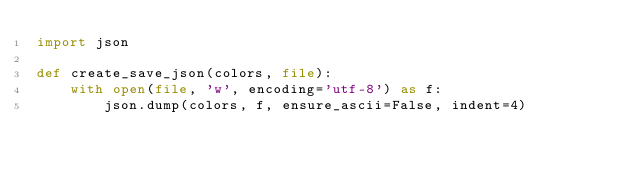<code> <loc_0><loc_0><loc_500><loc_500><_Python_>import json

def create_save_json(colors, file):
    with open(file, 'w', encoding='utf-8') as f:
        json.dump(colors, f, ensure_ascii=False, indent=4)</code> 